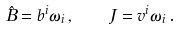Convert formula to latex. <formula><loc_0><loc_0><loc_500><loc_500>\hat { B } = b ^ { i } \omega _ { i } \, , \quad J = v ^ { i } \omega _ { i } \, .</formula> 